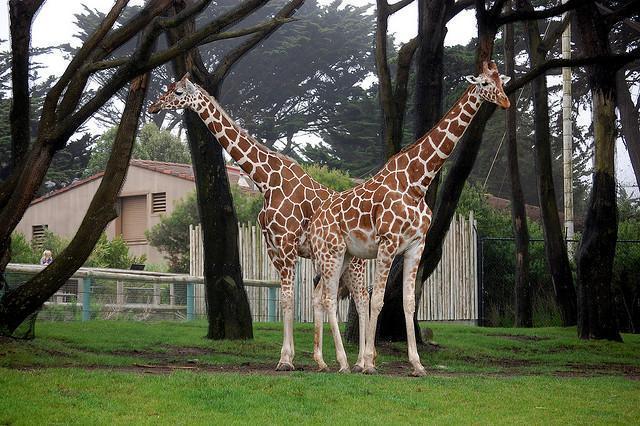How many giraffe are standing side by side?
Give a very brief answer. 2. How many giraffes are in the photo?
Give a very brief answer. 2. 